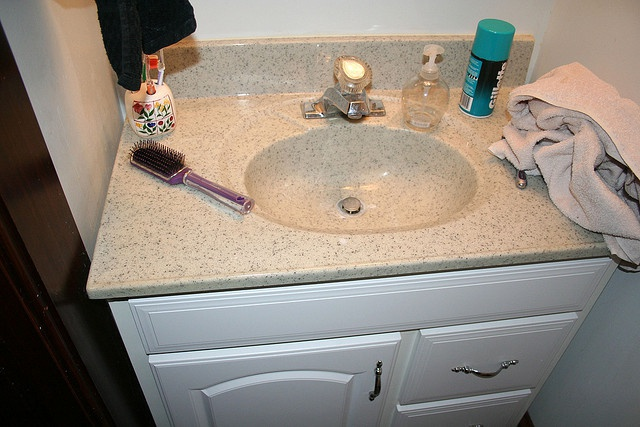Describe the objects in this image and their specific colors. I can see sink in gray, tan, and darkgray tones, bottle in gray, teal, and black tones, bottle in gray and tan tones, toothbrush in gray, salmon, brown, red, and tan tones, and toothbrush in gray, lightgray, darkgray, and tan tones in this image. 